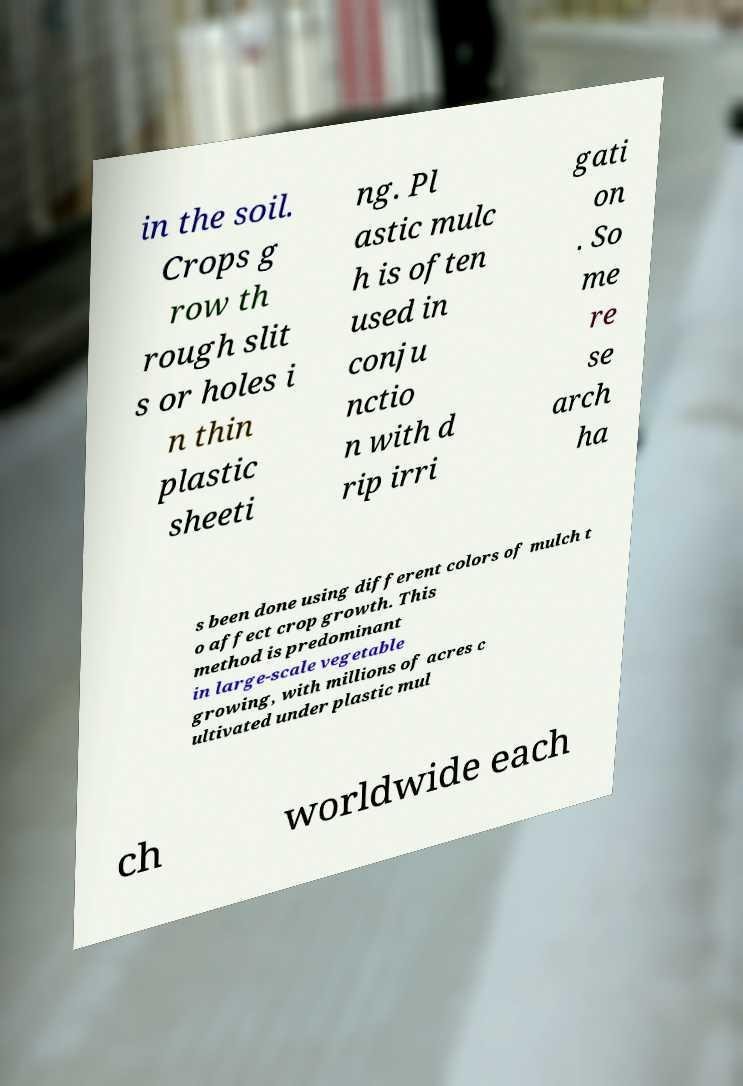Can you accurately transcribe the text from the provided image for me? in the soil. Crops g row th rough slit s or holes i n thin plastic sheeti ng. Pl astic mulc h is often used in conju nctio n with d rip irri gati on . So me re se arch ha s been done using different colors of mulch t o affect crop growth. This method is predominant in large-scale vegetable growing, with millions of acres c ultivated under plastic mul ch worldwide each 